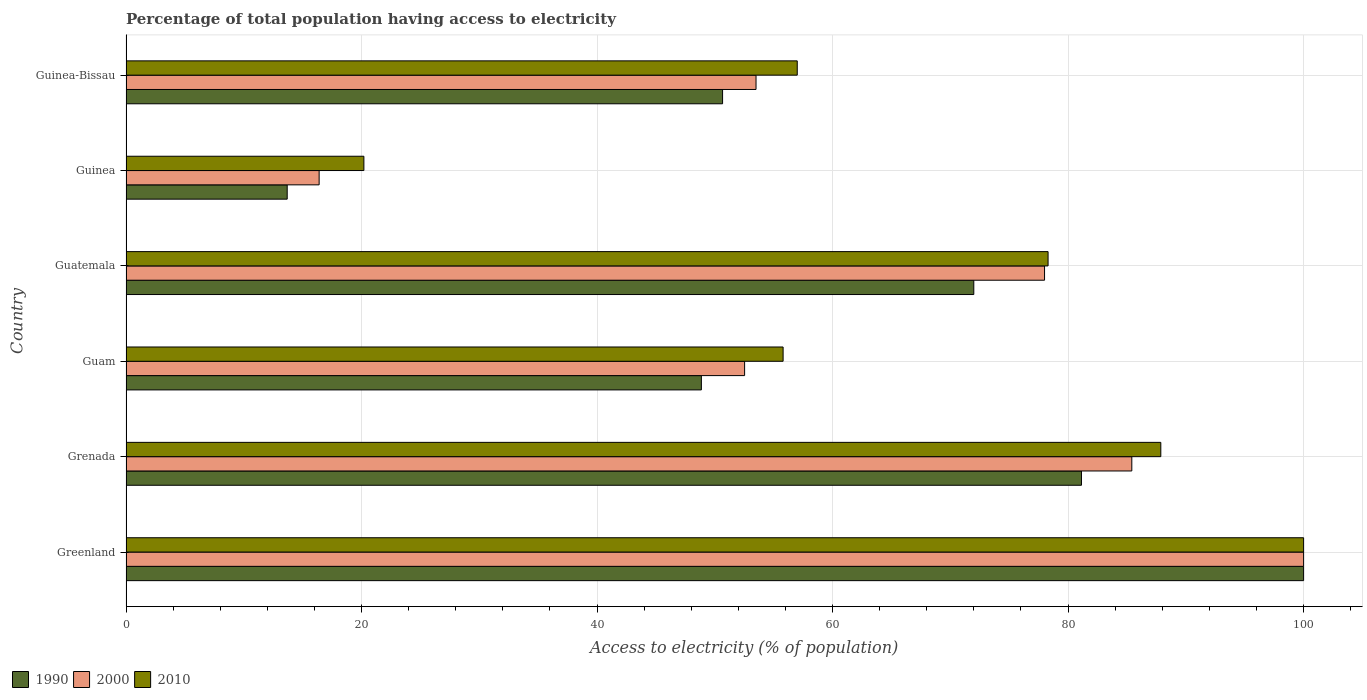How many different coloured bars are there?
Offer a very short reply. 3. Are the number of bars per tick equal to the number of legend labels?
Offer a very short reply. Yes. How many bars are there on the 3rd tick from the top?
Your answer should be compact. 3. What is the label of the 2nd group of bars from the top?
Your answer should be compact. Guinea. In how many cases, is the number of bars for a given country not equal to the number of legend labels?
Keep it short and to the point. 0. What is the percentage of population that have access to electricity in 2000 in Guinea-Bissau?
Provide a succinct answer. 53.5. Across all countries, what is the maximum percentage of population that have access to electricity in 1990?
Keep it short and to the point. 100. Across all countries, what is the minimum percentage of population that have access to electricity in 2010?
Offer a terse response. 20.2. In which country was the percentage of population that have access to electricity in 1990 maximum?
Make the answer very short. Greenland. In which country was the percentage of population that have access to electricity in 1990 minimum?
Keep it short and to the point. Guinea. What is the total percentage of population that have access to electricity in 1990 in the graph?
Provide a succinct answer. 366.33. What is the difference between the percentage of population that have access to electricity in 2010 in Guam and that in Guinea?
Offer a terse response. 35.6. What is the difference between the percentage of population that have access to electricity in 2010 in Guinea-Bissau and the percentage of population that have access to electricity in 1990 in Guinea?
Keep it short and to the point. 43.31. What is the average percentage of population that have access to electricity in 2010 per country?
Make the answer very short. 66.53. What is the difference between the percentage of population that have access to electricity in 2000 and percentage of population that have access to electricity in 1990 in Guinea-Bissau?
Offer a very short reply. 2.84. In how many countries, is the percentage of population that have access to electricity in 1990 greater than 96 %?
Your answer should be very brief. 1. What is the ratio of the percentage of population that have access to electricity in 2010 in Guam to that in Guatemala?
Provide a succinct answer. 0.71. Is the percentage of population that have access to electricity in 1990 in Grenada less than that in Guam?
Keep it short and to the point. No. What is the difference between the highest and the second highest percentage of population that have access to electricity in 2000?
Provide a succinct answer. 14.59. What is the difference between the highest and the lowest percentage of population that have access to electricity in 2000?
Provide a succinct answer. 83.6. In how many countries, is the percentage of population that have access to electricity in 2010 greater than the average percentage of population that have access to electricity in 2010 taken over all countries?
Ensure brevity in your answer.  3. What does the 2nd bar from the top in Guinea-Bissau represents?
Your answer should be very brief. 2000. What does the 2nd bar from the bottom in Guam represents?
Your answer should be very brief. 2000. Is it the case that in every country, the sum of the percentage of population that have access to electricity in 2010 and percentage of population that have access to electricity in 2000 is greater than the percentage of population that have access to electricity in 1990?
Offer a very short reply. Yes. Are all the bars in the graph horizontal?
Give a very brief answer. Yes. How many countries are there in the graph?
Make the answer very short. 6. Does the graph contain any zero values?
Offer a very short reply. No. Does the graph contain grids?
Provide a succinct answer. Yes. Where does the legend appear in the graph?
Give a very brief answer. Bottom left. What is the title of the graph?
Ensure brevity in your answer.  Percentage of total population having access to electricity. Does "1975" appear as one of the legend labels in the graph?
Offer a terse response. No. What is the label or title of the X-axis?
Your answer should be compact. Access to electricity (% of population). What is the label or title of the Y-axis?
Offer a terse response. Country. What is the Access to electricity (% of population) of 2010 in Greenland?
Offer a terse response. 100. What is the Access to electricity (% of population) in 1990 in Grenada?
Make the answer very short. 81.14. What is the Access to electricity (% of population) in 2000 in Grenada?
Your response must be concise. 85.41. What is the Access to electricity (% of population) in 2010 in Grenada?
Give a very brief answer. 87.87. What is the Access to electricity (% of population) in 1990 in Guam?
Provide a short and direct response. 48.86. What is the Access to electricity (% of population) in 2000 in Guam?
Offer a very short reply. 52.53. What is the Access to electricity (% of population) of 2010 in Guam?
Your answer should be compact. 55.8. What is the Access to electricity (% of population) in 1990 in Guatemala?
Your response must be concise. 71.99. What is the Access to electricity (% of population) of 2000 in Guatemala?
Offer a very short reply. 78. What is the Access to electricity (% of population) of 2010 in Guatemala?
Make the answer very short. 78.3. What is the Access to electricity (% of population) in 1990 in Guinea?
Provide a short and direct response. 13.69. What is the Access to electricity (% of population) of 2010 in Guinea?
Your response must be concise. 20.2. What is the Access to electricity (% of population) in 1990 in Guinea-Bissau?
Offer a terse response. 50.66. What is the Access to electricity (% of population) in 2000 in Guinea-Bissau?
Ensure brevity in your answer.  53.5. Across all countries, what is the maximum Access to electricity (% of population) of 1990?
Give a very brief answer. 100. Across all countries, what is the maximum Access to electricity (% of population) of 2000?
Make the answer very short. 100. Across all countries, what is the minimum Access to electricity (% of population) of 1990?
Your response must be concise. 13.69. Across all countries, what is the minimum Access to electricity (% of population) in 2000?
Your response must be concise. 16.4. Across all countries, what is the minimum Access to electricity (% of population) in 2010?
Ensure brevity in your answer.  20.2. What is the total Access to electricity (% of population) in 1990 in the graph?
Your answer should be compact. 366.33. What is the total Access to electricity (% of population) of 2000 in the graph?
Offer a terse response. 385.84. What is the total Access to electricity (% of population) of 2010 in the graph?
Offer a terse response. 399.17. What is the difference between the Access to electricity (% of population) of 1990 in Greenland and that in Grenada?
Your answer should be very brief. 18.86. What is the difference between the Access to electricity (% of population) in 2000 in Greenland and that in Grenada?
Provide a succinct answer. 14.59. What is the difference between the Access to electricity (% of population) in 2010 in Greenland and that in Grenada?
Your answer should be compact. 12.13. What is the difference between the Access to electricity (% of population) in 1990 in Greenland and that in Guam?
Ensure brevity in your answer.  51.14. What is the difference between the Access to electricity (% of population) of 2000 in Greenland and that in Guam?
Keep it short and to the point. 47.47. What is the difference between the Access to electricity (% of population) of 2010 in Greenland and that in Guam?
Give a very brief answer. 44.2. What is the difference between the Access to electricity (% of population) in 1990 in Greenland and that in Guatemala?
Make the answer very short. 28.01. What is the difference between the Access to electricity (% of population) of 2010 in Greenland and that in Guatemala?
Your response must be concise. 21.7. What is the difference between the Access to electricity (% of population) in 1990 in Greenland and that in Guinea?
Your answer should be compact. 86.31. What is the difference between the Access to electricity (% of population) in 2000 in Greenland and that in Guinea?
Keep it short and to the point. 83.6. What is the difference between the Access to electricity (% of population) of 2010 in Greenland and that in Guinea?
Ensure brevity in your answer.  79.8. What is the difference between the Access to electricity (% of population) in 1990 in Greenland and that in Guinea-Bissau?
Your answer should be compact. 49.34. What is the difference between the Access to electricity (% of population) of 2000 in Greenland and that in Guinea-Bissau?
Offer a very short reply. 46.5. What is the difference between the Access to electricity (% of population) of 1990 in Grenada and that in Guam?
Provide a short and direct response. 32.28. What is the difference between the Access to electricity (% of population) of 2000 in Grenada and that in Guam?
Offer a terse response. 32.88. What is the difference between the Access to electricity (% of population) of 2010 in Grenada and that in Guam?
Keep it short and to the point. 32.07. What is the difference between the Access to electricity (% of population) in 1990 in Grenada and that in Guatemala?
Your response must be concise. 9.14. What is the difference between the Access to electricity (% of population) in 2000 in Grenada and that in Guatemala?
Offer a very short reply. 7.41. What is the difference between the Access to electricity (% of population) in 2010 in Grenada and that in Guatemala?
Offer a very short reply. 9.57. What is the difference between the Access to electricity (% of population) in 1990 in Grenada and that in Guinea?
Your answer should be very brief. 67.45. What is the difference between the Access to electricity (% of population) of 2000 in Grenada and that in Guinea?
Provide a short and direct response. 69.01. What is the difference between the Access to electricity (% of population) in 2010 in Grenada and that in Guinea?
Give a very brief answer. 67.67. What is the difference between the Access to electricity (% of population) in 1990 in Grenada and that in Guinea-Bissau?
Ensure brevity in your answer.  30.48. What is the difference between the Access to electricity (% of population) of 2000 in Grenada and that in Guinea-Bissau?
Your answer should be compact. 31.91. What is the difference between the Access to electricity (% of population) of 2010 in Grenada and that in Guinea-Bissau?
Offer a terse response. 30.87. What is the difference between the Access to electricity (% of population) in 1990 in Guam and that in Guatemala?
Keep it short and to the point. -23.13. What is the difference between the Access to electricity (% of population) in 2000 in Guam and that in Guatemala?
Provide a short and direct response. -25.47. What is the difference between the Access to electricity (% of population) of 2010 in Guam and that in Guatemala?
Keep it short and to the point. -22.5. What is the difference between the Access to electricity (% of population) of 1990 in Guam and that in Guinea?
Your response must be concise. 35.17. What is the difference between the Access to electricity (% of population) of 2000 in Guam and that in Guinea?
Provide a succinct answer. 36.13. What is the difference between the Access to electricity (% of population) of 2010 in Guam and that in Guinea?
Keep it short and to the point. 35.6. What is the difference between the Access to electricity (% of population) of 1990 in Guam and that in Guinea-Bissau?
Your answer should be compact. -1.8. What is the difference between the Access to electricity (% of population) in 2000 in Guam and that in Guinea-Bissau?
Give a very brief answer. -0.97. What is the difference between the Access to electricity (% of population) in 2010 in Guam and that in Guinea-Bissau?
Give a very brief answer. -1.2. What is the difference between the Access to electricity (% of population) in 1990 in Guatemala and that in Guinea?
Make the answer very short. 58.3. What is the difference between the Access to electricity (% of population) of 2000 in Guatemala and that in Guinea?
Offer a very short reply. 61.6. What is the difference between the Access to electricity (% of population) in 2010 in Guatemala and that in Guinea?
Provide a succinct answer. 58.1. What is the difference between the Access to electricity (% of population) in 1990 in Guatemala and that in Guinea-Bissau?
Provide a succinct answer. 21.33. What is the difference between the Access to electricity (% of population) in 2000 in Guatemala and that in Guinea-Bissau?
Your answer should be very brief. 24.5. What is the difference between the Access to electricity (% of population) in 2010 in Guatemala and that in Guinea-Bissau?
Ensure brevity in your answer.  21.3. What is the difference between the Access to electricity (% of population) of 1990 in Guinea and that in Guinea-Bissau?
Ensure brevity in your answer.  -36.97. What is the difference between the Access to electricity (% of population) of 2000 in Guinea and that in Guinea-Bissau?
Provide a short and direct response. -37.1. What is the difference between the Access to electricity (% of population) in 2010 in Guinea and that in Guinea-Bissau?
Offer a very short reply. -36.8. What is the difference between the Access to electricity (% of population) of 1990 in Greenland and the Access to electricity (% of population) of 2000 in Grenada?
Provide a succinct answer. 14.59. What is the difference between the Access to electricity (% of population) of 1990 in Greenland and the Access to electricity (% of population) of 2010 in Grenada?
Offer a terse response. 12.13. What is the difference between the Access to electricity (% of population) in 2000 in Greenland and the Access to electricity (% of population) in 2010 in Grenada?
Give a very brief answer. 12.13. What is the difference between the Access to electricity (% of population) in 1990 in Greenland and the Access to electricity (% of population) in 2000 in Guam?
Give a very brief answer. 47.47. What is the difference between the Access to electricity (% of population) of 1990 in Greenland and the Access to electricity (% of population) of 2010 in Guam?
Your answer should be compact. 44.2. What is the difference between the Access to electricity (% of population) of 2000 in Greenland and the Access to electricity (% of population) of 2010 in Guam?
Offer a terse response. 44.2. What is the difference between the Access to electricity (% of population) of 1990 in Greenland and the Access to electricity (% of population) of 2000 in Guatemala?
Ensure brevity in your answer.  22. What is the difference between the Access to electricity (% of population) of 1990 in Greenland and the Access to electricity (% of population) of 2010 in Guatemala?
Your response must be concise. 21.7. What is the difference between the Access to electricity (% of population) of 2000 in Greenland and the Access to electricity (% of population) of 2010 in Guatemala?
Provide a succinct answer. 21.7. What is the difference between the Access to electricity (% of population) in 1990 in Greenland and the Access to electricity (% of population) in 2000 in Guinea?
Offer a terse response. 83.6. What is the difference between the Access to electricity (% of population) of 1990 in Greenland and the Access to electricity (% of population) of 2010 in Guinea?
Make the answer very short. 79.8. What is the difference between the Access to electricity (% of population) of 2000 in Greenland and the Access to electricity (% of population) of 2010 in Guinea?
Keep it short and to the point. 79.8. What is the difference between the Access to electricity (% of population) of 1990 in Greenland and the Access to electricity (% of population) of 2000 in Guinea-Bissau?
Make the answer very short. 46.5. What is the difference between the Access to electricity (% of population) of 2000 in Greenland and the Access to electricity (% of population) of 2010 in Guinea-Bissau?
Give a very brief answer. 43. What is the difference between the Access to electricity (% of population) of 1990 in Grenada and the Access to electricity (% of population) of 2000 in Guam?
Keep it short and to the point. 28.61. What is the difference between the Access to electricity (% of population) of 1990 in Grenada and the Access to electricity (% of population) of 2010 in Guam?
Keep it short and to the point. 25.34. What is the difference between the Access to electricity (% of population) in 2000 in Grenada and the Access to electricity (% of population) in 2010 in Guam?
Offer a very short reply. 29.61. What is the difference between the Access to electricity (% of population) of 1990 in Grenada and the Access to electricity (% of population) of 2000 in Guatemala?
Your response must be concise. 3.14. What is the difference between the Access to electricity (% of population) of 1990 in Grenada and the Access to electricity (% of population) of 2010 in Guatemala?
Keep it short and to the point. 2.84. What is the difference between the Access to electricity (% of population) in 2000 in Grenada and the Access to electricity (% of population) in 2010 in Guatemala?
Offer a terse response. 7.11. What is the difference between the Access to electricity (% of population) in 1990 in Grenada and the Access to electricity (% of population) in 2000 in Guinea?
Your answer should be compact. 64.74. What is the difference between the Access to electricity (% of population) in 1990 in Grenada and the Access to electricity (% of population) in 2010 in Guinea?
Make the answer very short. 60.94. What is the difference between the Access to electricity (% of population) of 2000 in Grenada and the Access to electricity (% of population) of 2010 in Guinea?
Keep it short and to the point. 65.21. What is the difference between the Access to electricity (% of population) of 1990 in Grenada and the Access to electricity (% of population) of 2000 in Guinea-Bissau?
Your answer should be very brief. 27.64. What is the difference between the Access to electricity (% of population) in 1990 in Grenada and the Access to electricity (% of population) in 2010 in Guinea-Bissau?
Make the answer very short. 24.14. What is the difference between the Access to electricity (% of population) in 2000 in Grenada and the Access to electricity (% of population) in 2010 in Guinea-Bissau?
Your response must be concise. 28.41. What is the difference between the Access to electricity (% of population) in 1990 in Guam and the Access to electricity (% of population) in 2000 in Guatemala?
Offer a very short reply. -29.14. What is the difference between the Access to electricity (% of population) of 1990 in Guam and the Access to electricity (% of population) of 2010 in Guatemala?
Ensure brevity in your answer.  -29.44. What is the difference between the Access to electricity (% of population) in 2000 in Guam and the Access to electricity (% of population) in 2010 in Guatemala?
Provide a short and direct response. -25.77. What is the difference between the Access to electricity (% of population) of 1990 in Guam and the Access to electricity (% of population) of 2000 in Guinea?
Your answer should be compact. 32.46. What is the difference between the Access to electricity (% of population) in 1990 in Guam and the Access to electricity (% of population) in 2010 in Guinea?
Provide a succinct answer. 28.66. What is the difference between the Access to electricity (% of population) of 2000 in Guam and the Access to electricity (% of population) of 2010 in Guinea?
Ensure brevity in your answer.  32.33. What is the difference between the Access to electricity (% of population) of 1990 in Guam and the Access to electricity (% of population) of 2000 in Guinea-Bissau?
Your answer should be compact. -4.64. What is the difference between the Access to electricity (% of population) of 1990 in Guam and the Access to electricity (% of population) of 2010 in Guinea-Bissau?
Offer a terse response. -8.14. What is the difference between the Access to electricity (% of population) in 2000 in Guam and the Access to electricity (% of population) in 2010 in Guinea-Bissau?
Your response must be concise. -4.47. What is the difference between the Access to electricity (% of population) in 1990 in Guatemala and the Access to electricity (% of population) in 2000 in Guinea?
Your response must be concise. 55.59. What is the difference between the Access to electricity (% of population) in 1990 in Guatemala and the Access to electricity (% of population) in 2010 in Guinea?
Ensure brevity in your answer.  51.79. What is the difference between the Access to electricity (% of population) in 2000 in Guatemala and the Access to electricity (% of population) in 2010 in Guinea?
Offer a terse response. 57.8. What is the difference between the Access to electricity (% of population) of 1990 in Guatemala and the Access to electricity (% of population) of 2000 in Guinea-Bissau?
Your answer should be very brief. 18.49. What is the difference between the Access to electricity (% of population) in 1990 in Guatemala and the Access to electricity (% of population) in 2010 in Guinea-Bissau?
Your answer should be very brief. 14.99. What is the difference between the Access to electricity (% of population) in 1990 in Guinea and the Access to electricity (% of population) in 2000 in Guinea-Bissau?
Offer a very short reply. -39.81. What is the difference between the Access to electricity (% of population) of 1990 in Guinea and the Access to electricity (% of population) of 2010 in Guinea-Bissau?
Provide a succinct answer. -43.31. What is the difference between the Access to electricity (% of population) in 2000 in Guinea and the Access to electricity (% of population) in 2010 in Guinea-Bissau?
Your response must be concise. -40.6. What is the average Access to electricity (% of population) of 1990 per country?
Provide a succinct answer. 61.06. What is the average Access to electricity (% of population) in 2000 per country?
Your answer should be very brief. 64.31. What is the average Access to electricity (% of population) in 2010 per country?
Make the answer very short. 66.53. What is the difference between the Access to electricity (% of population) in 1990 and Access to electricity (% of population) in 2010 in Greenland?
Ensure brevity in your answer.  0. What is the difference between the Access to electricity (% of population) in 1990 and Access to electricity (% of population) in 2000 in Grenada?
Provide a short and direct response. -4.28. What is the difference between the Access to electricity (% of population) of 1990 and Access to electricity (% of population) of 2010 in Grenada?
Make the answer very short. -6.74. What is the difference between the Access to electricity (% of population) in 2000 and Access to electricity (% of population) in 2010 in Grenada?
Offer a very short reply. -2.46. What is the difference between the Access to electricity (% of population) in 1990 and Access to electricity (% of population) in 2000 in Guam?
Offer a very short reply. -3.67. What is the difference between the Access to electricity (% of population) of 1990 and Access to electricity (% of population) of 2010 in Guam?
Ensure brevity in your answer.  -6.94. What is the difference between the Access to electricity (% of population) in 2000 and Access to electricity (% of population) in 2010 in Guam?
Provide a short and direct response. -3.27. What is the difference between the Access to electricity (% of population) in 1990 and Access to electricity (% of population) in 2000 in Guatemala?
Your answer should be very brief. -6.01. What is the difference between the Access to electricity (% of population) in 1990 and Access to electricity (% of population) in 2010 in Guatemala?
Ensure brevity in your answer.  -6.31. What is the difference between the Access to electricity (% of population) in 2000 and Access to electricity (% of population) in 2010 in Guatemala?
Offer a terse response. -0.3. What is the difference between the Access to electricity (% of population) of 1990 and Access to electricity (% of population) of 2000 in Guinea?
Make the answer very short. -2.71. What is the difference between the Access to electricity (% of population) in 1990 and Access to electricity (% of population) in 2010 in Guinea?
Give a very brief answer. -6.51. What is the difference between the Access to electricity (% of population) of 2000 and Access to electricity (% of population) of 2010 in Guinea?
Offer a very short reply. -3.8. What is the difference between the Access to electricity (% of population) in 1990 and Access to electricity (% of population) in 2000 in Guinea-Bissau?
Give a very brief answer. -2.84. What is the difference between the Access to electricity (% of population) of 1990 and Access to electricity (% of population) of 2010 in Guinea-Bissau?
Offer a terse response. -6.34. What is the difference between the Access to electricity (% of population) in 2000 and Access to electricity (% of population) in 2010 in Guinea-Bissau?
Your answer should be compact. -3.5. What is the ratio of the Access to electricity (% of population) of 1990 in Greenland to that in Grenada?
Offer a terse response. 1.23. What is the ratio of the Access to electricity (% of population) of 2000 in Greenland to that in Grenada?
Make the answer very short. 1.17. What is the ratio of the Access to electricity (% of population) of 2010 in Greenland to that in Grenada?
Make the answer very short. 1.14. What is the ratio of the Access to electricity (% of population) in 1990 in Greenland to that in Guam?
Make the answer very short. 2.05. What is the ratio of the Access to electricity (% of population) of 2000 in Greenland to that in Guam?
Provide a short and direct response. 1.9. What is the ratio of the Access to electricity (% of population) in 2010 in Greenland to that in Guam?
Provide a short and direct response. 1.79. What is the ratio of the Access to electricity (% of population) in 1990 in Greenland to that in Guatemala?
Offer a terse response. 1.39. What is the ratio of the Access to electricity (% of population) of 2000 in Greenland to that in Guatemala?
Give a very brief answer. 1.28. What is the ratio of the Access to electricity (% of population) in 2010 in Greenland to that in Guatemala?
Keep it short and to the point. 1.28. What is the ratio of the Access to electricity (% of population) in 1990 in Greenland to that in Guinea?
Provide a short and direct response. 7.31. What is the ratio of the Access to electricity (% of population) of 2000 in Greenland to that in Guinea?
Ensure brevity in your answer.  6.1. What is the ratio of the Access to electricity (% of population) of 2010 in Greenland to that in Guinea?
Your response must be concise. 4.95. What is the ratio of the Access to electricity (% of population) in 1990 in Greenland to that in Guinea-Bissau?
Your answer should be very brief. 1.97. What is the ratio of the Access to electricity (% of population) of 2000 in Greenland to that in Guinea-Bissau?
Provide a short and direct response. 1.87. What is the ratio of the Access to electricity (% of population) of 2010 in Greenland to that in Guinea-Bissau?
Offer a terse response. 1.75. What is the ratio of the Access to electricity (% of population) in 1990 in Grenada to that in Guam?
Your answer should be very brief. 1.66. What is the ratio of the Access to electricity (% of population) in 2000 in Grenada to that in Guam?
Your answer should be compact. 1.63. What is the ratio of the Access to electricity (% of population) in 2010 in Grenada to that in Guam?
Keep it short and to the point. 1.57. What is the ratio of the Access to electricity (% of population) of 1990 in Grenada to that in Guatemala?
Make the answer very short. 1.13. What is the ratio of the Access to electricity (% of population) of 2000 in Grenada to that in Guatemala?
Your answer should be compact. 1.09. What is the ratio of the Access to electricity (% of population) of 2010 in Grenada to that in Guatemala?
Your answer should be very brief. 1.12. What is the ratio of the Access to electricity (% of population) in 1990 in Grenada to that in Guinea?
Keep it short and to the point. 5.93. What is the ratio of the Access to electricity (% of population) in 2000 in Grenada to that in Guinea?
Offer a very short reply. 5.21. What is the ratio of the Access to electricity (% of population) of 2010 in Grenada to that in Guinea?
Offer a very short reply. 4.35. What is the ratio of the Access to electricity (% of population) in 1990 in Grenada to that in Guinea-Bissau?
Make the answer very short. 1.6. What is the ratio of the Access to electricity (% of population) of 2000 in Grenada to that in Guinea-Bissau?
Provide a succinct answer. 1.6. What is the ratio of the Access to electricity (% of population) in 2010 in Grenada to that in Guinea-Bissau?
Give a very brief answer. 1.54. What is the ratio of the Access to electricity (% of population) in 1990 in Guam to that in Guatemala?
Provide a succinct answer. 0.68. What is the ratio of the Access to electricity (% of population) in 2000 in Guam to that in Guatemala?
Offer a terse response. 0.67. What is the ratio of the Access to electricity (% of population) of 2010 in Guam to that in Guatemala?
Provide a short and direct response. 0.71. What is the ratio of the Access to electricity (% of population) of 1990 in Guam to that in Guinea?
Provide a short and direct response. 3.57. What is the ratio of the Access to electricity (% of population) of 2000 in Guam to that in Guinea?
Your response must be concise. 3.2. What is the ratio of the Access to electricity (% of population) of 2010 in Guam to that in Guinea?
Give a very brief answer. 2.76. What is the ratio of the Access to electricity (% of population) in 1990 in Guam to that in Guinea-Bissau?
Provide a short and direct response. 0.96. What is the ratio of the Access to electricity (% of population) of 2000 in Guam to that in Guinea-Bissau?
Keep it short and to the point. 0.98. What is the ratio of the Access to electricity (% of population) of 2010 in Guam to that in Guinea-Bissau?
Make the answer very short. 0.98. What is the ratio of the Access to electricity (% of population) in 1990 in Guatemala to that in Guinea?
Your answer should be very brief. 5.26. What is the ratio of the Access to electricity (% of population) in 2000 in Guatemala to that in Guinea?
Your answer should be compact. 4.76. What is the ratio of the Access to electricity (% of population) of 2010 in Guatemala to that in Guinea?
Keep it short and to the point. 3.88. What is the ratio of the Access to electricity (% of population) in 1990 in Guatemala to that in Guinea-Bissau?
Give a very brief answer. 1.42. What is the ratio of the Access to electricity (% of population) of 2000 in Guatemala to that in Guinea-Bissau?
Give a very brief answer. 1.46. What is the ratio of the Access to electricity (% of population) of 2010 in Guatemala to that in Guinea-Bissau?
Offer a terse response. 1.37. What is the ratio of the Access to electricity (% of population) of 1990 in Guinea to that in Guinea-Bissau?
Your response must be concise. 0.27. What is the ratio of the Access to electricity (% of population) of 2000 in Guinea to that in Guinea-Bissau?
Give a very brief answer. 0.31. What is the ratio of the Access to electricity (% of population) in 2010 in Guinea to that in Guinea-Bissau?
Provide a short and direct response. 0.35. What is the difference between the highest and the second highest Access to electricity (% of population) of 1990?
Provide a succinct answer. 18.86. What is the difference between the highest and the second highest Access to electricity (% of population) of 2000?
Offer a terse response. 14.59. What is the difference between the highest and the second highest Access to electricity (% of population) in 2010?
Ensure brevity in your answer.  12.13. What is the difference between the highest and the lowest Access to electricity (% of population) in 1990?
Your answer should be compact. 86.31. What is the difference between the highest and the lowest Access to electricity (% of population) in 2000?
Keep it short and to the point. 83.6. What is the difference between the highest and the lowest Access to electricity (% of population) of 2010?
Offer a terse response. 79.8. 